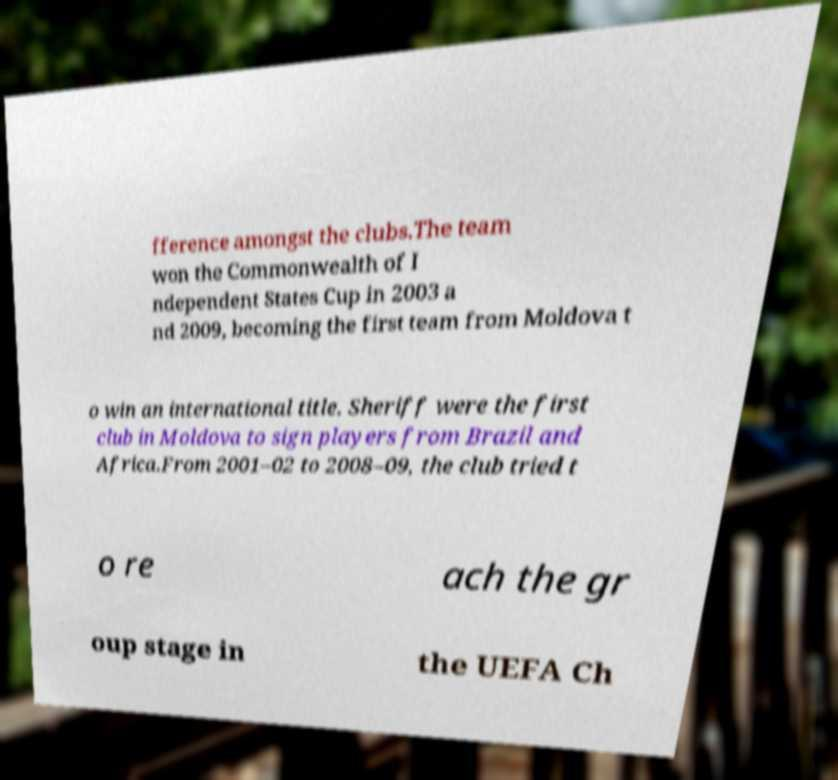Could you assist in decoding the text presented in this image and type it out clearly? fference amongst the clubs.The team won the Commonwealth of I ndependent States Cup in 2003 a nd 2009, becoming the first team from Moldova t o win an international title. Sheriff were the first club in Moldova to sign players from Brazil and Africa.From 2001–02 to 2008–09, the club tried t o re ach the gr oup stage in the UEFA Ch 